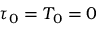Convert formula to latex. <formula><loc_0><loc_0><loc_500><loc_500>\tau _ { 0 } = T _ { 0 } = 0</formula> 